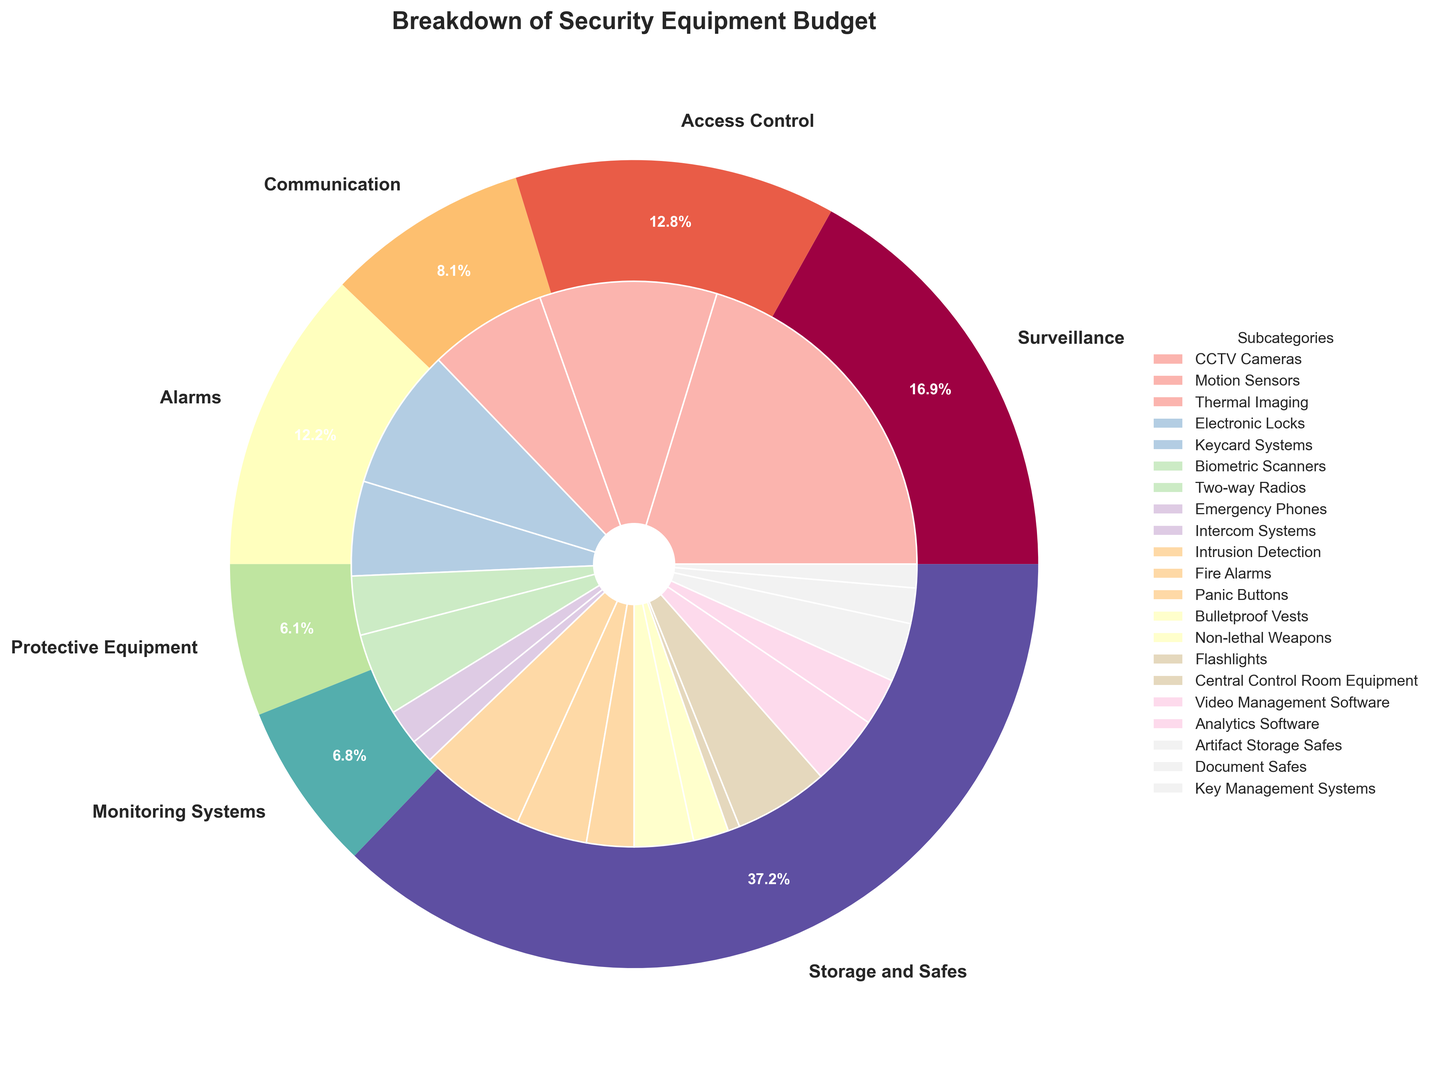Which category has the highest percentage of the budget? Look at the outer pie chart and identify the category that occupies the largest section. The Surveillance section has the largest slice.
Answer: Surveillance What is the total budget percentage allocated to Communication and Alarms combined? Locate the Communication and Alarms sections in the outer pie chart. Communication is 12% and Alarms is 13%. Add these percentages together: 12 + 13 = 25%.
Answer: 25% Which subcategory within Surveillance has the highest budget allocation? Look at the inner pie sections within the Surveillance category. Identify the largest section, which is CCTV Cameras.
Answer: CCTV Cameras How does the budget for Biometric Scanners compare to the budget for Emergency Phones? Find these subcategories within their respective categories in the inner pie chart. Biometric Scanners have a smaller slice compared to Emergency Phones.
Answer: Emergency Phones have a higher budget Which subcategory in Monitoring Systems has the smallest budget allocation? Look at the inner pie sections within Monitoring Systems. Analytics Software has the smallest section.
Answer: Analytics Software What is the combined budget allocation for Intrusion Detection and Fire Alarms? Locate these subcategories under Alarms in the inner pie chart. Intrusion Detection is 9% and Fire Alarms is 6%. Add these percentages together: 9 + 6 = 15%.
Answer: 15% Compare the budget allocated to Artifact Storage Safes to that of Bulletproof Vests. Which one is higher, and by how much? Find these subcategories in the inner pie chart. Artifact Storage Safes is 5% and Bulletproof Vests is 5%. They are equal, so there is no difference.
Answer: Equal What is the percentage difference between the total budget for Access Control and the Monitoring Systems? First, find the total percentages for both categories in the outer pie chart. Access Control is 25% and Monitoring Systems is 18%. Calculate the difference: 25 - 18 = 7%.
Answer: 7% Which has a higher budget allocation: Non-lethal Weapons or Flashlights? Find these subcategories in the inner pie chart. Non-lethal Weapons have a larger section than Flashlights.
Answer: Non-lethal Weapons What's the budget percentage for Key Management Systems compared to the total percentage allocated to Protective Equipment? Locate Key Management Systems in the inner pie and Protective Equipment in the outer pie chart. Key Management Systems is 2%. Protective Equipment is 18%.
Answer: 2% vs. 18% 